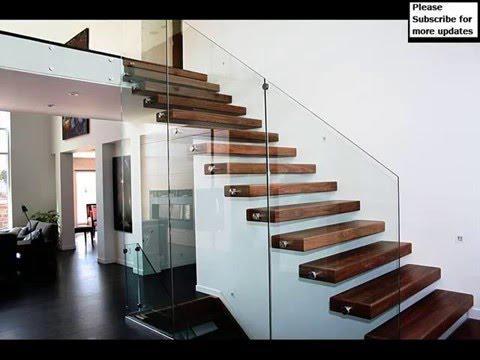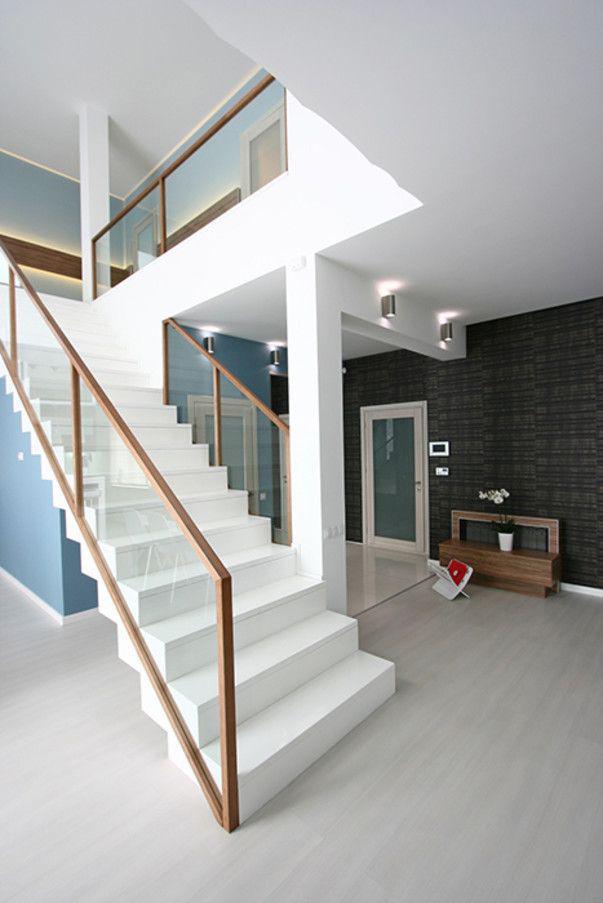The first image is the image on the left, the second image is the image on the right. For the images shown, is this caption "One image shows a staircase leading down to the right, with glass panels along the side and flat brown wooden backless steps." true? Answer yes or no. Yes. 